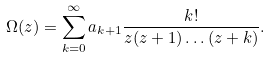Convert formula to latex. <formula><loc_0><loc_0><loc_500><loc_500>\Omega ( z ) = \sum _ { k = 0 } ^ { \infty } a _ { k + 1 } \frac { k ! } { z ( z + 1 ) \dots ( z + k ) } .</formula> 